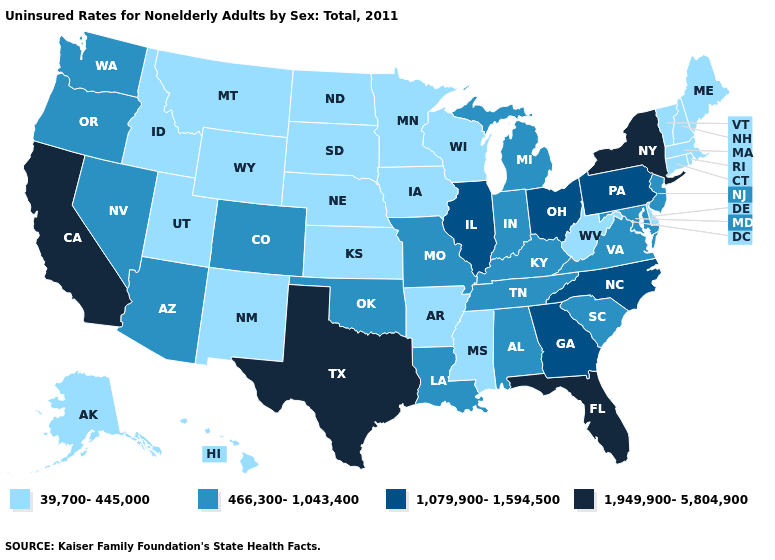Among the states that border Mississippi , does Arkansas have the lowest value?
Write a very short answer. Yes. Which states hav the highest value in the West?
Be succinct. California. Which states hav the highest value in the South?
Be succinct. Florida, Texas. Is the legend a continuous bar?
Give a very brief answer. No. Does Wyoming have a lower value than Louisiana?
Be succinct. Yes. Which states hav the highest value in the West?
Write a very short answer. California. Name the states that have a value in the range 39,700-445,000?
Keep it brief. Alaska, Arkansas, Connecticut, Delaware, Hawaii, Idaho, Iowa, Kansas, Maine, Massachusetts, Minnesota, Mississippi, Montana, Nebraska, New Hampshire, New Mexico, North Dakota, Rhode Island, South Dakota, Utah, Vermont, West Virginia, Wisconsin, Wyoming. Name the states that have a value in the range 1,079,900-1,594,500?
Keep it brief. Georgia, Illinois, North Carolina, Ohio, Pennsylvania. What is the value of Arizona?
Answer briefly. 466,300-1,043,400. Among the states that border Mississippi , which have the highest value?
Write a very short answer. Alabama, Louisiana, Tennessee. What is the highest value in the USA?
Answer briefly. 1,949,900-5,804,900. Which states have the lowest value in the USA?
Quick response, please. Alaska, Arkansas, Connecticut, Delaware, Hawaii, Idaho, Iowa, Kansas, Maine, Massachusetts, Minnesota, Mississippi, Montana, Nebraska, New Hampshire, New Mexico, North Dakota, Rhode Island, South Dakota, Utah, Vermont, West Virginia, Wisconsin, Wyoming. What is the value of Illinois?
Give a very brief answer. 1,079,900-1,594,500. Does the map have missing data?
Keep it brief. No. What is the value of Rhode Island?
Answer briefly. 39,700-445,000. 